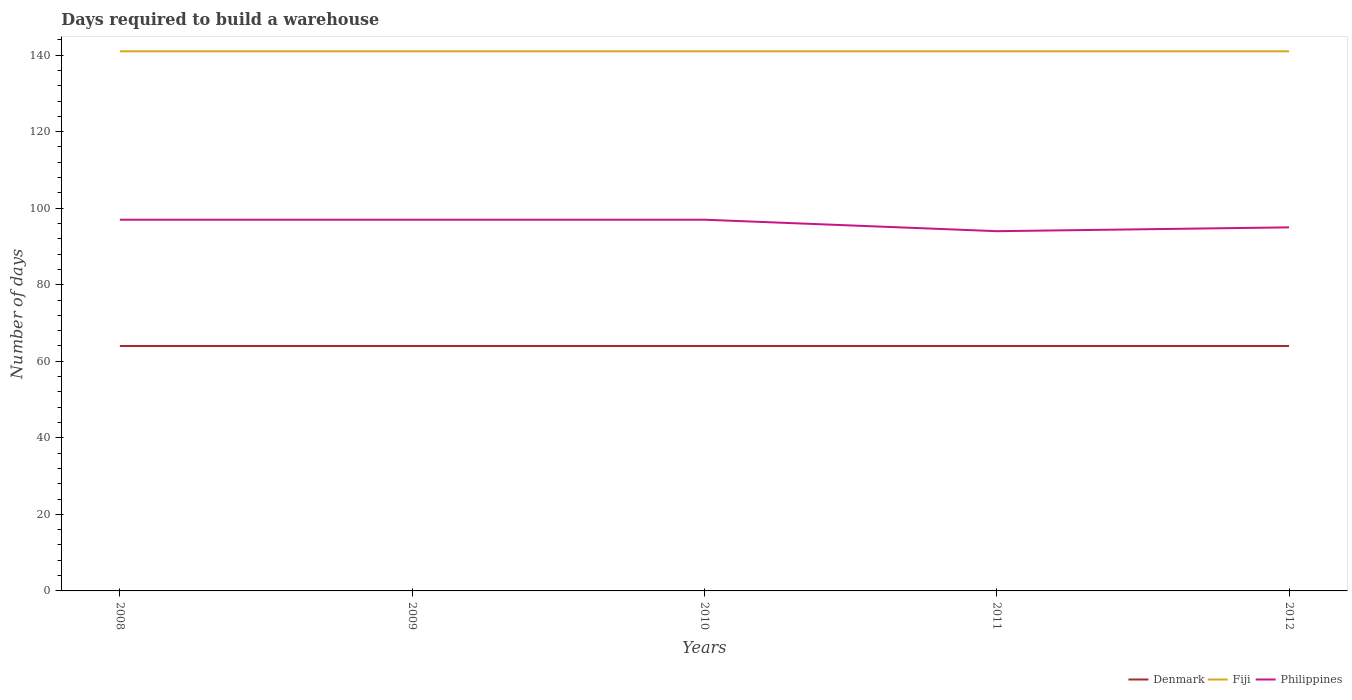Does the line corresponding to Denmark intersect with the line corresponding to Fiji?
Provide a succinct answer. No. Across all years, what is the maximum days required to build a warehouse in in Philippines?
Your answer should be very brief. 94. What is the total days required to build a warehouse in in Philippines in the graph?
Your answer should be compact. 2. What is the difference between the highest and the second highest days required to build a warehouse in in Philippines?
Provide a short and direct response. 3. Where does the legend appear in the graph?
Provide a succinct answer. Bottom right. What is the title of the graph?
Offer a very short reply. Days required to build a warehouse. What is the label or title of the X-axis?
Offer a very short reply. Years. What is the label or title of the Y-axis?
Your response must be concise. Number of days. What is the Number of days of Denmark in 2008?
Keep it short and to the point. 64. What is the Number of days in Fiji in 2008?
Provide a short and direct response. 141. What is the Number of days of Philippines in 2008?
Provide a short and direct response. 97. What is the Number of days of Fiji in 2009?
Give a very brief answer. 141. What is the Number of days in Philippines in 2009?
Provide a succinct answer. 97. What is the Number of days in Fiji in 2010?
Ensure brevity in your answer.  141. What is the Number of days in Philippines in 2010?
Provide a succinct answer. 97. What is the Number of days in Fiji in 2011?
Keep it short and to the point. 141. What is the Number of days of Philippines in 2011?
Make the answer very short. 94. What is the Number of days of Fiji in 2012?
Offer a terse response. 141. What is the Number of days in Philippines in 2012?
Offer a very short reply. 95. Across all years, what is the maximum Number of days in Denmark?
Provide a succinct answer. 64. Across all years, what is the maximum Number of days in Fiji?
Keep it short and to the point. 141. Across all years, what is the maximum Number of days in Philippines?
Provide a short and direct response. 97. Across all years, what is the minimum Number of days in Fiji?
Ensure brevity in your answer.  141. Across all years, what is the minimum Number of days in Philippines?
Make the answer very short. 94. What is the total Number of days of Denmark in the graph?
Make the answer very short. 320. What is the total Number of days in Fiji in the graph?
Provide a short and direct response. 705. What is the total Number of days in Philippines in the graph?
Make the answer very short. 480. What is the difference between the Number of days in Fiji in 2008 and that in 2009?
Provide a short and direct response. 0. What is the difference between the Number of days in Philippines in 2008 and that in 2009?
Make the answer very short. 0. What is the difference between the Number of days of Fiji in 2008 and that in 2010?
Provide a succinct answer. 0. What is the difference between the Number of days in Denmark in 2008 and that in 2011?
Make the answer very short. 0. What is the difference between the Number of days in Fiji in 2008 and that in 2011?
Make the answer very short. 0. What is the difference between the Number of days of Philippines in 2008 and that in 2011?
Offer a very short reply. 3. What is the difference between the Number of days in Fiji in 2008 and that in 2012?
Provide a succinct answer. 0. What is the difference between the Number of days in Denmark in 2009 and that in 2011?
Your response must be concise. 0. What is the difference between the Number of days of Philippines in 2009 and that in 2011?
Make the answer very short. 3. What is the difference between the Number of days in Denmark in 2009 and that in 2012?
Your answer should be compact. 0. What is the difference between the Number of days in Fiji in 2009 and that in 2012?
Provide a short and direct response. 0. What is the difference between the Number of days in Fiji in 2010 and that in 2011?
Make the answer very short. 0. What is the difference between the Number of days in Philippines in 2010 and that in 2011?
Offer a very short reply. 3. What is the difference between the Number of days in Denmark in 2010 and that in 2012?
Provide a succinct answer. 0. What is the difference between the Number of days of Philippines in 2011 and that in 2012?
Keep it short and to the point. -1. What is the difference between the Number of days in Denmark in 2008 and the Number of days in Fiji in 2009?
Offer a very short reply. -77. What is the difference between the Number of days in Denmark in 2008 and the Number of days in Philippines in 2009?
Provide a succinct answer. -33. What is the difference between the Number of days of Fiji in 2008 and the Number of days of Philippines in 2009?
Make the answer very short. 44. What is the difference between the Number of days of Denmark in 2008 and the Number of days of Fiji in 2010?
Offer a very short reply. -77. What is the difference between the Number of days in Denmark in 2008 and the Number of days in Philippines in 2010?
Your answer should be compact. -33. What is the difference between the Number of days in Denmark in 2008 and the Number of days in Fiji in 2011?
Your answer should be compact. -77. What is the difference between the Number of days of Denmark in 2008 and the Number of days of Fiji in 2012?
Give a very brief answer. -77. What is the difference between the Number of days of Denmark in 2008 and the Number of days of Philippines in 2012?
Provide a short and direct response. -31. What is the difference between the Number of days of Fiji in 2008 and the Number of days of Philippines in 2012?
Ensure brevity in your answer.  46. What is the difference between the Number of days in Denmark in 2009 and the Number of days in Fiji in 2010?
Provide a succinct answer. -77. What is the difference between the Number of days of Denmark in 2009 and the Number of days of Philippines in 2010?
Your answer should be very brief. -33. What is the difference between the Number of days of Fiji in 2009 and the Number of days of Philippines in 2010?
Provide a short and direct response. 44. What is the difference between the Number of days in Denmark in 2009 and the Number of days in Fiji in 2011?
Your answer should be very brief. -77. What is the difference between the Number of days of Denmark in 2009 and the Number of days of Philippines in 2011?
Keep it short and to the point. -30. What is the difference between the Number of days of Denmark in 2009 and the Number of days of Fiji in 2012?
Provide a short and direct response. -77. What is the difference between the Number of days in Denmark in 2009 and the Number of days in Philippines in 2012?
Ensure brevity in your answer.  -31. What is the difference between the Number of days of Fiji in 2009 and the Number of days of Philippines in 2012?
Offer a terse response. 46. What is the difference between the Number of days of Denmark in 2010 and the Number of days of Fiji in 2011?
Keep it short and to the point. -77. What is the difference between the Number of days of Fiji in 2010 and the Number of days of Philippines in 2011?
Offer a very short reply. 47. What is the difference between the Number of days in Denmark in 2010 and the Number of days in Fiji in 2012?
Offer a very short reply. -77. What is the difference between the Number of days of Denmark in 2010 and the Number of days of Philippines in 2012?
Ensure brevity in your answer.  -31. What is the difference between the Number of days in Fiji in 2010 and the Number of days in Philippines in 2012?
Make the answer very short. 46. What is the difference between the Number of days of Denmark in 2011 and the Number of days of Fiji in 2012?
Your response must be concise. -77. What is the difference between the Number of days of Denmark in 2011 and the Number of days of Philippines in 2012?
Ensure brevity in your answer.  -31. What is the difference between the Number of days of Fiji in 2011 and the Number of days of Philippines in 2012?
Offer a very short reply. 46. What is the average Number of days in Fiji per year?
Offer a very short reply. 141. What is the average Number of days of Philippines per year?
Offer a terse response. 96. In the year 2008, what is the difference between the Number of days in Denmark and Number of days in Fiji?
Your response must be concise. -77. In the year 2008, what is the difference between the Number of days in Denmark and Number of days in Philippines?
Offer a terse response. -33. In the year 2009, what is the difference between the Number of days in Denmark and Number of days in Fiji?
Provide a short and direct response. -77. In the year 2009, what is the difference between the Number of days in Denmark and Number of days in Philippines?
Make the answer very short. -33. In the year 2009, what is the difference between the Number of days of Fiji and Number of days of Philippines?
Keep it short and to the point. 44. In the year 2010, what is the difference between the Number of days in Denmark and Number of days in Fiji?
Your answer should be compact. -77. In the year 2010, what is the difference between the Number of days of Denmark and Number of days of Philippines?
Make the answer very short. -33. In the year 2011, what is the difference between the Number of days in Denmark and Number of days in Fiji?
Your answer should be very brief. -77. In the year 2012, what is the difference between the Number of days in Denmark and Number of days in Fiji?
Provide a short and direct response. -77. In the year 2012, what is the difference between the Number of days in Denmark and Number of days in Philippines?
Offer a very short reply. -31. What is the ratio of the Number of days in Denmark in 2008 to that in 2009?
Your answer should be compact. 1. What is the ratio of the Number of days of Philippines in 2008 to that in 2009?
Your response must be concise. 1. What is the ratio of the Number of days of Philippines in 2008 to that in 2010?
Your answer should be compact. 1. What is the ratio of the Number of days in Fiji in 2008 to that in 2011?
Keep it short and to the point. 1. What is the ratio of the Number of days of Philippines in 2008 to that in 2011?
Offer a very short reply. 1.03. What is the ratio of the Number of days of Fiji in 2008 to that in 2012?
Provide a short and direct response. 1. What is the ratio of the Number of days of Philippines in 2008 to that in 2012?
Offer a terse response. 1.02. What is the ratio of the Number of days of Denmark in 2009 to that in 2010?
Your answer should be compact. 1. What is the ratio of the Number of days in Fiji in 2009 to that in 2010?
Offer a very short reply. 1. What is the ratio of the Number of days in Philippines in 2009 to that in 2010?
Offer a terse response. 1. What is the ratio of the Number of days of Denmark in 2009 to that in 2011?
Offer a terse response. 1. What is the ratio of the Number of days of Fiji in 2009 to that in 2011?
Offer a terse response. 1. What is the ratio of the Number of days of Philippines in 2009 to that in 2011?
Your answer should be very brief. 1.03. What is the ratio of the Number of days of Fiji in 2009 to that in 2012?
Provide a succinct answer. 1. What is the ratio of the Number of days in Philippines in 2009 to that in 2012?
Make the answer very short. 1.02. What is the ratio of the Number of days in Fiji in 2010 to that in 2011?
Give a very brief answer. 1. What is the ratio of the Number of days of Philippines in 2010 to that in 2011?
Give a very brief answer. 1.03. What is the ratio of the Number of days of Denmark in 2010 to that in 2012?
Provide a short and direct response. 1. What is the ratio of the Number of days in Philippines in 2010 to that in 2012?
Your answer should be very brief. 1.02. What is the difference between the highest and the second highest Number of days in Fiji?
Offer a terse response. 0. What is the difference between the highest and the lowest Number of days of Denmark?
Provide a succinct answer. 0. What is the difference between the highest and the lowest Number of days in Fiji?
Offer a terse response. 0. 